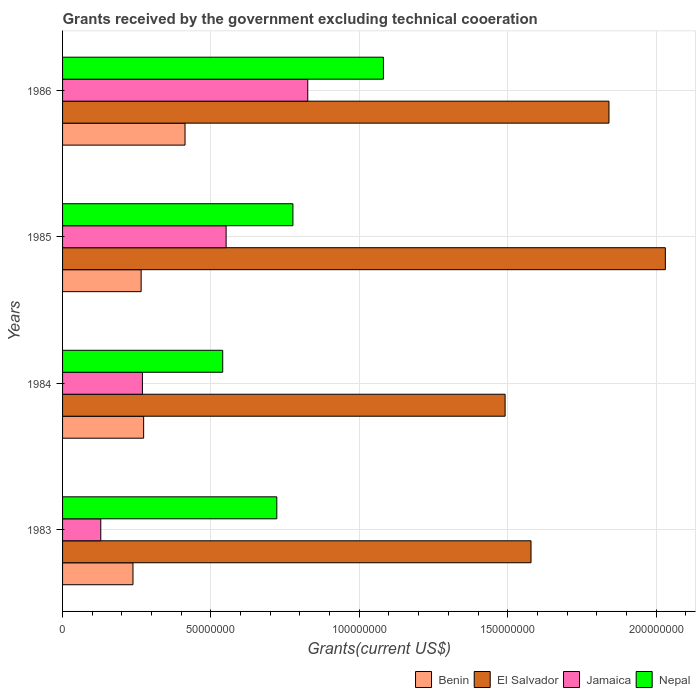How many different coloured bars are there?
Your response must be concise. 4. Are the number of bars per tick equal to the number of legend labels?
Make the answer very short. Yes. Are the number of bars on each tick of the Y-axis equal?
Keep it short and to the point. Yes. How many bars are there on the 3rd tick from the top?
Make the answer very short. 4. In how many cases, is the number of bars for a given year not equal to the number of legend labels?
Your answer should be compact. 0. What is the total grants received by the government in Nepal in 1983?
Your response must be concise. 7.22e+07. Across all years, what is the maximum total grants received by the government in El Salvador?
Ensure brevity in your answer.  2.03e+08. Across all years, what is the minimum total grants received by the government in Jamaica?
Your answer should be compact. 1.29e+07. What is the total total grants received by the government in El Salvador in the graph?
Your answer should be very brief. 6.94e+08. What is the difference between the total grants received by the government in Benin in 1984 and that in 1985?
Offer a very short reply. 8.40e+05. What is the difference between the total grants received by the government in Benin in 1985 and the total grants received by the government in Nepal in 1983?
Provide a succinct answer. -4.57e+07. What is the average total grants received by the government in Benin per year?
Make the answer very short. 2.97e+07. In the year 1983, what is the difference between the total grants received by the government in El Salvador and total grants received by the government in Nepal?
Provide a short and direct response. 8.57e+07. In how many years, is the total grants received by the government in El Salvador greater than 20000000 US$?
Your answer should be compact. 4. What is the ratio of the total grants received by the government in Jamaica in 1985 to that in 1986?
Ensure brevity in your answer.  0.67. Is the total grants received by the government in Nepal in 1983 less than that in 1985?
Offer a terse response. Yes. Is the difference between the total grants received by the government in El Salvador in 1984 and 1986 greater than the difference between the total grants received by the government in Nepal in 1984 and 1986?
Your response must be concise. Yes. What is the difference between the highest and the second highest total grants received by the government in El Salvador?
Give a very brief answer. 1.90e+07. What is the difference between the highest and the lowest total grants received by the government in El Salvador?
Provide a short and direct response. 5.40e+07. In how many years, is the total grants received by the government in Benin greater than the average total grants received by the government in Benin taken over all years?
Ensure brevity in your answer.  1. Is it the case that in every year, the sum of the total grants received by the government in Benin and total grants received by the government in Jamaica is greater than the sum of total grants received by the government in El Salvador and total grants received by the government in Nepal?
Your response must be concise. No. What does the 3rd bar from the top in 1983 represents?
Your answer should be very brief. El Salvador. What does the 2nd bar from the bottom in 1984 represents?
Keep it short and to the point. El Salvador. Is it the case that in every year, the sum of the total grants received by the government in El Salvador and total grants received by the government in Nepal is greater than the total grants received by the government in Jamaica?
Offer a terse response. Yes. How many bars are there?
Ensure brevity in your answer.  16. Are all the bars in the graph horizontal?
Provide a succinct answer. Yes. How many years are there in the graph?
Offer a terse response. 4. Does the graph contain any zero values?
Give a very brief answer. No. Does the graph contain grids?
Offer a very short reply. Yes. Where does the legend appear in the graph?
Offer a very short reply. Bottom right. How many legend labels are there?
Keep it short and to the point. 4. How are the legend labels stacked?
Offer a terse response. Horizontal. What is the title of the graph?
Ensure brevity in your answer.  Grants received by the government excluding technical cooeration. Does "Trinidad and Tobago" appear as one of the legend labels in the graph?
Ensure brevity in your answer.  No. What is the label or title of the X-axis?
Make the answer very short. Grants(current US$). What is the Grants(current US$) of Benin in 1983?
Your answer should be compact. 2.37e+07. What is the Grants(current US$) in El Salvador in 1983?
Your answer should be very brief. 1.58e+08. What is the Grants(current US$) of Jamaica in 1983?
Make the answer very short. 1.29e+07. What is the Grants(current US$) in Nepal in 1983?
Give a very brief answer. 7.22e+07. What is the Grants(current US$) of Benin in 1984?
Give a very brief answer. 2.73e+07. What is the Grants(current US$) in El Salvador in 1984?
Provide a succinct answer. 1.49e+08. What is the Grants(current US$) in Jamaica in 1984?
Give a very brief answer. 2.69e+07. What is the Grants(current US$) of Nepal in 1984?
Provide a short and direct response. 5.40e+07. What is the Grants(current US$) of Benin in 1985?
Provide a short and direct response. 2.65e+07. What is the Grants(current US$) of El Salvador in 1985?
Your response must be concise. 2.03e+08. What is the Grants(current US$) of Jamaica in 1985?
Your answer should be compact. 5.51e+07. What is the Grants(current US$) in Nepal in 1985?
Provide a succinct answer. 7.76e+07. What is the Grants(current US$) of Benin in 1986?
Give a very brief answer. 4.13e+07. What is the Grants(current US$) of El Salvador in 1986?
Give a very brief answer. 1.84e+08. What is the Grants(current US$) in Jamaica in 1986?
Make the answer very short. 8.26e+07. What is the Grants(current US$) of Nepal in 1986?
Ensure brevity in your answer.  1.08e+08. Across all years, what is the maximum Grants(current US$) in Benin?
Your answer should be very brief. 4.13e+07. Across all years, what is the maximum Grants(current US$) of El Salvador?
Provide a short and direct response. 2.03e+08. Across all years, what is the maximum Grants(current US$) in Jamaica?
Offer a very short reply. 8.26e+07. Across all years, what is the maximum Grants(current US$) in Nepal?
Give a very brief answer. 1.08e+08. Across all years, what is the minimum Grants(current US$) in Benin?
Give a very brief answer. 2.37e+07. Across all years, what is the minimum Grants(current US$) in El Salvador?
Provide a succinct answer. 1.49e+08. Across all years, what is the minimum Grants(current US$) of Jamaica?
Provide a short and direct response. 1.29e+07. Across all years, what is the minimum Grants(current US$) of Nepal?
Your answer should be compact. 5.40e+07. What is the total Grants(current US$) of Benin in the graph?
Your response must be concise. 1.19e+08. What is the total Grants(current US$) in El Salvador in the graph?
Provide a short and direct response. 6.94e+08. What is the total Grants(current US$) in Jamaica in the graph?
Make the answer very short. 1.78e+08. What is the total Grants(current US$) of Nepal in the graph?
Offer a very short reply. 3.12e+08. What is the difference between the Grants(current US$) in Benin in 1983 and that in 1984?
Provide a succinct answer. -3.59e+06. What is the difference between the Grants(current US$) of El Salvador in 1983 and that in 1984?
Your answer should be very brief. 8.73e+06. What is the difference between the Grants(current US$) in Jamaica in 1983 and that in 1984?
Provide a short and direct response. -1.40e+07. What is the difference between the Grants(current US$) in Nepal in 1983 and that in 1984?
Offer a very short reply. 1.82e+07. What is the difference between the Grants(current US$) in Benin in 1983 and that in 1985?
Give a very brief answer. -2.75e+06. What is the difference between the Grants(current US$) in El Salvador in 1983 and that in 1985?
Your response must be concise. -4.53e+07. What is the difference between the Grants(current US$) in Jamaica in 1983 and that in 1985?
Your response must be concise. -4.22e+07. What is the difference between the Grants(current US$) of Nepal in 1983 and that in 1985?
Offer a terse response. -5.43e+06. What is the difference between the Grants(current US$) in Benin in 1983 and that in 1986?
Provide a succinct answer. -1.75e+07. What is the difference between the Grants(current US$) of El Salvador in 1983 and that in 1986?
Give a very brief answer. -2.63e+07. What is the difference between the Grants(current US$) of Jamaica in 1983 and that in 1986?
Your answer should be very brief. -6.98e+07. What is the difference between the Grants(current US$) of Nepal in 1983 and that in 1986?
Your response must be concise. -3.59e+07. What is the difference between the Grants(current US$) of Benin in 1984 and that in 1985?
Provide a short and direct response. 8.40e+05. What is the difference between the Grants(current US$) in El Salvador in 1984 and that in 1985?
Keep it short and to the point. -5.40e+07. What is the difference between the Grants(current US$) of Jamaica in 1984 and that in 1985?
Keep it short and to the point. -2.82e+07. What is the difference between the Grants(current US$) in Nepal in 1984 and that in 1985?
Provide a short and direct response. -2.37e+07. What is the difference between the Grants(current US$) in Benin in 1984 and that in 1986?
Your answer should be very brief. -1.40e+07. What is the difference between the Grants(current US$) of El Salvador in 1984 and that in 1986?
Ensure brevity in your answer.  -3.50e+07. What is the difference between the Grants(current US$) in Jamaica in 1984 and that in 1986?
Your answer should be compact. -5.57e+07. What is the difference between the Grants(current US$) of Nepal in 1984 and that in 1986?
Give a very brief answer. -5.42e+07. What is the difference between the Grants(current US$) of Benin in 1985 and that in 1986?
Ensure brevity in your answer.  -1.48e+07. What is the difference between the Grants(current US$) of El Salvador in 1985 and that in 1986?
Your answer should be very brief. 1.90e+07. What is the difference between the Grants(current US$) of Jamaica in 1985 and that in 1986?
Your response must be concise. -2.75e+07. What is the difference between the Grants(current US$) in Nepal in 1985 and that in 1986?
Your answer should be very brief. -3.05e+07. What is the difference between the Grants(current US$) in Benin in 1983 and the Grants(current US$) in El Salvador in 1984?
Your response must be concise. -1.25e+08. What is the difference between the Grants(current US$) in Benin in 1983 and the Grants(current US$) in Jamaica in 1984?
Make the answer very short. -3.18e+06. What is the difference between the Grants(current US$) of Benin in 1983 and the Grants(current US$) of Nepal in 1984?
Keep it short and to the point. -3.02e+07. What is the difference between the Grants(current US$) of El Salvador in 1983 and the Grants(current US$) of Jamaica in 1984?
Your response must be concise. 1.31e+08. What is the difference between the Grants(current US$) of El Salvador in 1983 and the Grants(current US$) of Nepal in 1984?
Keep it short and to the point. 1.04e+08. What is the difference between the Grants(current US$) of Jamaica in 1983 and the Grants(current US$) of Nepal in 1984?
Offer a terse response. -4.11e+07. What is the difference between the Grants(current US$) of Benin in 1983 and the Grants(current US$) of El Salvador in 1985?
Provide a short and direct response. -1.79e+08. What is the difference between the Grants(current US$) in Benin in 1983 and the Grants(current US$) in Jamaica in 1985?
Offer a very short reply. -3.14e+07. What is the difference between the Grants(current US$) in Benin in 1983 and the Grants(current US$) in Nepal in 1985?
Your response must be concise. -5.39e+07. What is the difference between the Grants(current US$) of El Salvador in 1983 and the Grants(current US$) of Jamaica in 1985?
Make the answer very short. 1.03e+08. What is the difference between the Grants(current US$) of El Salvador in 1983 and the Grants(current US$) of Nepal in 1985?
Give a very brief answer. 8.02e+07. What is the difference between the Grants(current US$) in Jamaica in 1983 and the Grants(current US$) in Nepal in 1985?
Your response must be concise. -6.48e+07. What is the difference between the Grants(current US$) of Benin in 1983 and the Grants(current US$) of El Salvador in 1986?
Make the answer very short. -1.60e+08. What is the difference between the Grants(current US$) of Benin in 1983 and the Grants(current US$) of Jamaica in 1986?
Your answer should be compact. -5.89e+07. What is the difference between the Grants(current US$) of Benin in 1983 and the Grants(current US$) of Nepal in 1986?
Ensure brevity in your answer.  -8.44e+07. What is the difference between the Grants(current US$) of El Salvador in 1983 and the Grants(current US$) of Jamaica in 1986?
Your answer should be compact. 7.52e+07. What is the difference between the Grants(current US$) in El Salvador in 1983 and the Grants(current US$) in Nepal in 1986?
Make the answer very short. 4.97e+07. What is the difference between the Grants(current US$) of Jamaica in 1983 and the Grants(current US$) of Nepal in 1986?
Offer a terse response. -9.52e+07. What is the difference between the Grants(current US$) of Benin in 1984 and the Grants(current US$) of El Salvador in 1985?
Ensure brevity in your answer.  -1.76e+08. What is the difference between the Grants(current US$) in Benin in 1984 and the Grants(current US$) in Jamaica in 1985?
Offer a terse response. -2.78e+07. What is the difference between the Grants(current US$) in Benin in 1984 and the Grants(current US$) in Nepal in 1985?
Your response must be concise. -5.03e+07. What is the difference between the Grants(current US$) in El Salvador in 1984 and the Grants(current US$) in Jamaica in 1985?
Give a very brief answer. 9.40e+07. What is the difference between the Grants(current US$) of El Salvador in 1984 and the Grants(current US$) of Nepal in 1985?
Your answer should be very brief. 7.15e+07. What is the difference between the Grants(current US$) of Jamaica in 1984 and the Grants(current US$) of Nepal in 1985?
Offer a very short reply. -5.07e+07. What is the difference between the Grants(current US$) of Benin in 1984 and the Grants(current US$) of El Salvador in 1986?
Your response must be concise. -1.57e+08. What is the difference between the Grants(current US$) of Benin in 1984 and the Grants(current US$) of Jamaica in 1986?
Offer a terse response. -5.53e+07. What is the difference between the Grants(current US$) in Benin in 1984 and the Grants(current US$) in Nepal in 1986?
Give a very brief answer. -8.08e+07. What is the difference between the Grants(current US$) of El Salvador in 1984 and the Grants(current US$) of Jamaica in 1986?
Your answer should be very brief. 6.65e+07. What is the difference between the Grants(current US$) in El Salvador in 1984 and the Grants(current US$) in Nepal in 1986?
Keep it short and to the point. 4.10e+07. What is the difference between the Grants(current US$) in Jamaica in 1984 and the Grants(current US$) in Nepal in 1986?
Your answer should be very brief. -8.12e+07. What is the difference between the Grants(current US$) in Benin in 1985 and the Grants(current US$) in El Salvador in 1986?
Your answer should be compact. -1.58e+08. What is the difference between the Grants(current US$) in Benin in 1985 and the Grants(current US$) in Jamaica in 1986?
Your response must be concise. -5.62e+07. What is the difference between the Grants(current US$) in Benin in 1985 and the Grants(current US$) in Nepal in 1986?
Your response must be concise. -8.16e+07. What is the difference between the Grants(current US$) of El Salvador in 1985 and the Grants(current US$) of Jamaica in 1986?
Offer a very short reply. 1.21e+08. What is the difference between the Grants(current US$) of El Salvador in 1985 and the Grants(current US$) of Nepal in 1986?
Keep it short and to the point. 9.50e+07. What is the difference between the Grants(current US$) in Jamaica in 1985 and the Grants(current US$) in Nepal in 1986?
Provide a short and direct response. -5.30e+07. What is the average Grants(current US$) in Benin per year?
Provide a succinct answer. 2.97e+07. What is the average Grants(current US$) of El Salvador per year?
Make the answer very short. 1.74e+08. What is the average Grants(current US$) of Jamaica per year?
Your answer should be very brief. 4.44e+07. What is the average Grants(current US$) of Nepal per year?
Offer a very short reply. 7.80e+07. In the year 1983, what is the difference between the Grants(current US$) of Benin and Grants(current US$) of El Salvador?
Offer a terse response. -1.34e+08. In the year 1983, what is the difference between the Grants(current US$) of Benin and Grants(current US$) of Jamaica?
Offer a very short reply. 1.08e+07. In the year 1983, what is the difference between the Grants(current US$) in Benin and Grants(current US$) in Nepal?
Keep it short and to the point. -4.85e+07. In the year 1983, what is the difference between the Grants(current US$) in El Salvador and Grants(current US$) in Jamaica?
Provide a short and direct response. 1.45e+08. In the year 1983, what is the difference between the Grants(current US$) in El Salvador and Grants(current US$) in Nepal?
Your response must be concise. 8.57e+07. In the year 1983, what is the difference between the Grants(current US$) in Jamaica and Grants(current US$) in Nepal?
Keep it short and to the point. -5.93e+07. In the year 1984, what is the difference between the Grants(current US$) of Benin and Grants(current US$) of El Salvador?
Your answer should be very brief. -1.22e+08. In the year 1984, what is the difference between the Grants(current US$) of Benin and Grants(current US$) of Nepal?
Provide a succinct answer. -2.66e+07. In the year 1984, what is the difference between the Grants(current US$) of El Salvador and Grants(current US$) of Jamaica?
Offer a terse response. 1.22e+08. In the year 1984, what is the difference between the Grants(current US$) of El Salvador and Grants(current US$) of Nepal?
Provide a succinct answer. 9.52e+07. In the year 1984, what is the difference between the Grants(current US$) in Jamaica and Grants(current US$) in Nepal?
Provide a succinct answer. -2.71e+07. In the year 1985, what is the difference between the Grants(current US$) of Benin and Grants(current US$) of El Salvador?
Provide a short and direct response. -1.77e+08. In the year 1985, what is the difference between the Grants(current US$) in Benin and Grants(current US$) in Jamaica?
Provide a succinct answer. -2.86e+07. In the year 1985, what is the difference between the Grants(current US$) in Benin and Grants(current US$) in Nepal?
Your answer should be compact. -5.12e+07. In the year 1985, what is the difference between the Grants(current US$) in El Salvador and Grants(current US$) in Jamaica?
Provide a succinct answer. 1.48e+08. In the year 1985, what is the difference between the Grants(current US$) in El Salvador and Grants(current US$) in Nepal?
Offer a very short reply. 1.26e+08. In the year 1985, what is the difference between the Grants(current US$) of Jamaica and Grants(current US$) of Nepal?
Offer a very short reply. -2.25e+07. In the year 1986, what is the difference between the Grants(current US$) of Benin and Grants(current US$) of El Salvador?
Offer a terse response. -1.43e+08. In the year 1986, what is the difference between the Grants(current US$) of Benin and Grants(current US$) of Jamaica?
Offer a very short reply. -4.14e+07. In the year 1986, what is the difference between the Grants(current US$) of Benin and Grants(current US$) of Nepal?
Make the answer very short. -6.69e+07. In the year 1986, what is the difference between the Grants(current US$) in El Salvador and Grants(current US$) in Jamaica?
Make the answer very short. 1.02e+08. In the year 1986, what is the difference between the Grants(current US$) in El Salvador and Grants(current US$) in Nepal?
Your answer should be very brief. 7.60e+07. In the year 1986, what is the difference between the Grants(current US$) of Jamaica and Grants(current US$) of Nepal?
Offer a terse response. -2.55e+07. What is the ratio of the Grants(current US$) in Benin in 1983 to that in 1984?
Keep it short and to the point. 0.87. What is the ratio of the Grants(current US$) of El Salvador in 1983 to that in 1984?
Your response must be concise. 1.06. What is the ratio of the Grants(current US$) in Jamaica in 1983 to that in 1984?
Offer a very short reply. 0.48. What is the ratio of the Grants(current US$) of Nepal in 1983 to that in 1984?
Give a very brief answer. 1.34. What is the ratio of the Grants(current US$) in Benin in 1983 to that in 1985?
Offer a very short reply. 0.9. What is the ratio of the Grants(current US$) in El Salvador in 1983 to that in 1985?
Give a very brief answer. 0.78. What is the ratio of the Grants(current US$) of Jamaica in 1983 to that in 1985?
Ensure brevity in your answer.  0.23. What is the ratio of the Grants(current US$) of Nepal in 1983 to that in 1985?
Your response must be concise. 0.93. What is the ratio of the Grants(current US$) of Benin in 1983 to that in 1986?
Your response must be concise. 0.57. What is the ratio of the Grants(current US$) in El Salvador in 1983 to that in 1986?
Give a very brief answer. 0.86. What is the ratio of the Grants(current US$) of Jamaica in 1983 to that in 1986?
Keep it short and to the point. 0.16. What is the ratio of the Grants(current US$) of Nepal in 1983 to that in 1986?
Make the answer very short. 0.67. What is the ratio of the Grants(current US$) of Benin in 1984 to that in 1985?
Offer a very short reply. 1.03. What is the ratio of the Grants(current US$) in El Salvador in 1984 to that in 1985?
Offer a terse response. 0.73. What is the ratio of the Grants(current US$) in Jamaica in 1984 to that in 1985?
Your response must be concise. 0.49. What is the ratio of the Grants(current US$) of Nepal in 1984 to that in 1985?
Offer a very short reply. 0.7. What is the ratio of the Grants(current US$) in Benin in 1984 to that in 1986?
Ensure brevity in your answer.  0.66. What is the ratio of the Grants(current US$) of El Salvador in 1984 to that in 1986?
Your response must be concise. 0.81. What is the ratio of the Grants(current US$) in Jamaica in 1984 to that in 1986?
Give a very brief answer. 0.33. What is the ratio of the Grants(current US$) in Nepal in 1984 to that in 1986?
Your answer should be compact. 0.5. What is the ratio of the Grants(current US$) of Benin in 1985 to that in 1986?
Keep it short and to the point. 0.64. What is the ratio of the Grants(current US$) of El Salvador in 1985 to that in 1986?
Keep it short and to the point. 1.1. What is the ratio of the Grants(current US$) in Jamaica in 1985 to that in 1986?
Provide a succinct answer. 0.67. What is the ratio of the Grants(current US$) of Nepal in 1985 to that in 1986?
Your answer should be compact. 0.72. What is the difference between the highest and the second highest Grants(current US$) of Benin?
Ensure brevity in your answer.  1.40e+07. What is the difference between the highest and the second highest Grants(current US$) of El Salvador?
Your response must be concise. 1.90e+07. What is the difference between the highest and the second highest Grants(current US$) of Jamaica?
Offer a terse response. 2.75e+07. What is the difference between the highest and the second highest Grants(current US$) in Nepal?
Your answer should be compact. 3.05e+07. What is the difference between the highest and the lowest Grants(current US$) of Benin?
Give a very brief answer. 1.75e+07. What is the difference between the highest and the lowest Grants(current US$) in El Salvador?
Ensure brevity in your answer.  5.40e+07. What is the difference between the highest and the lowest Grants(current US$) in Jamaica?
Make the answer very short. 6.98e+07. What is the difference between the highest and the lowest Grants(current US$) of Nepal?
Offer a terse response. 5.42e+07. 